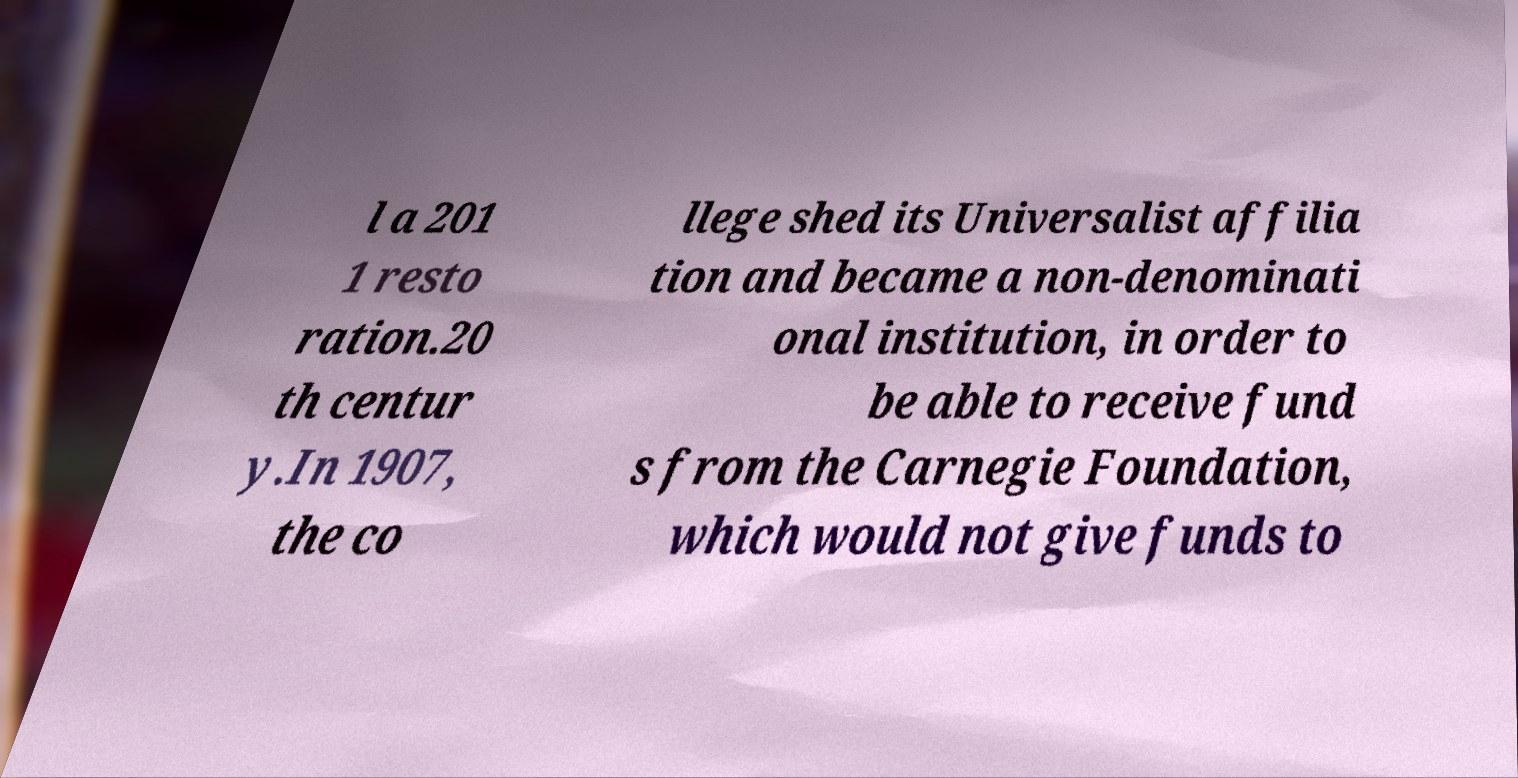For documentation purposes, I need the text within this image transcribed. Could you provide that? l a 201 1 resto ration.20 th centur y.In 1907, the co llege shed its Universalist affilia tion and became a non-denominati onal institution, in order to be able to receive fund s from the Carnegie Foundation, which would not give funds to 